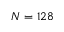Convert formula to latex. <formula><loc_0><loc_0><loc_500><loc_500>N = 1 2 8</formula> 